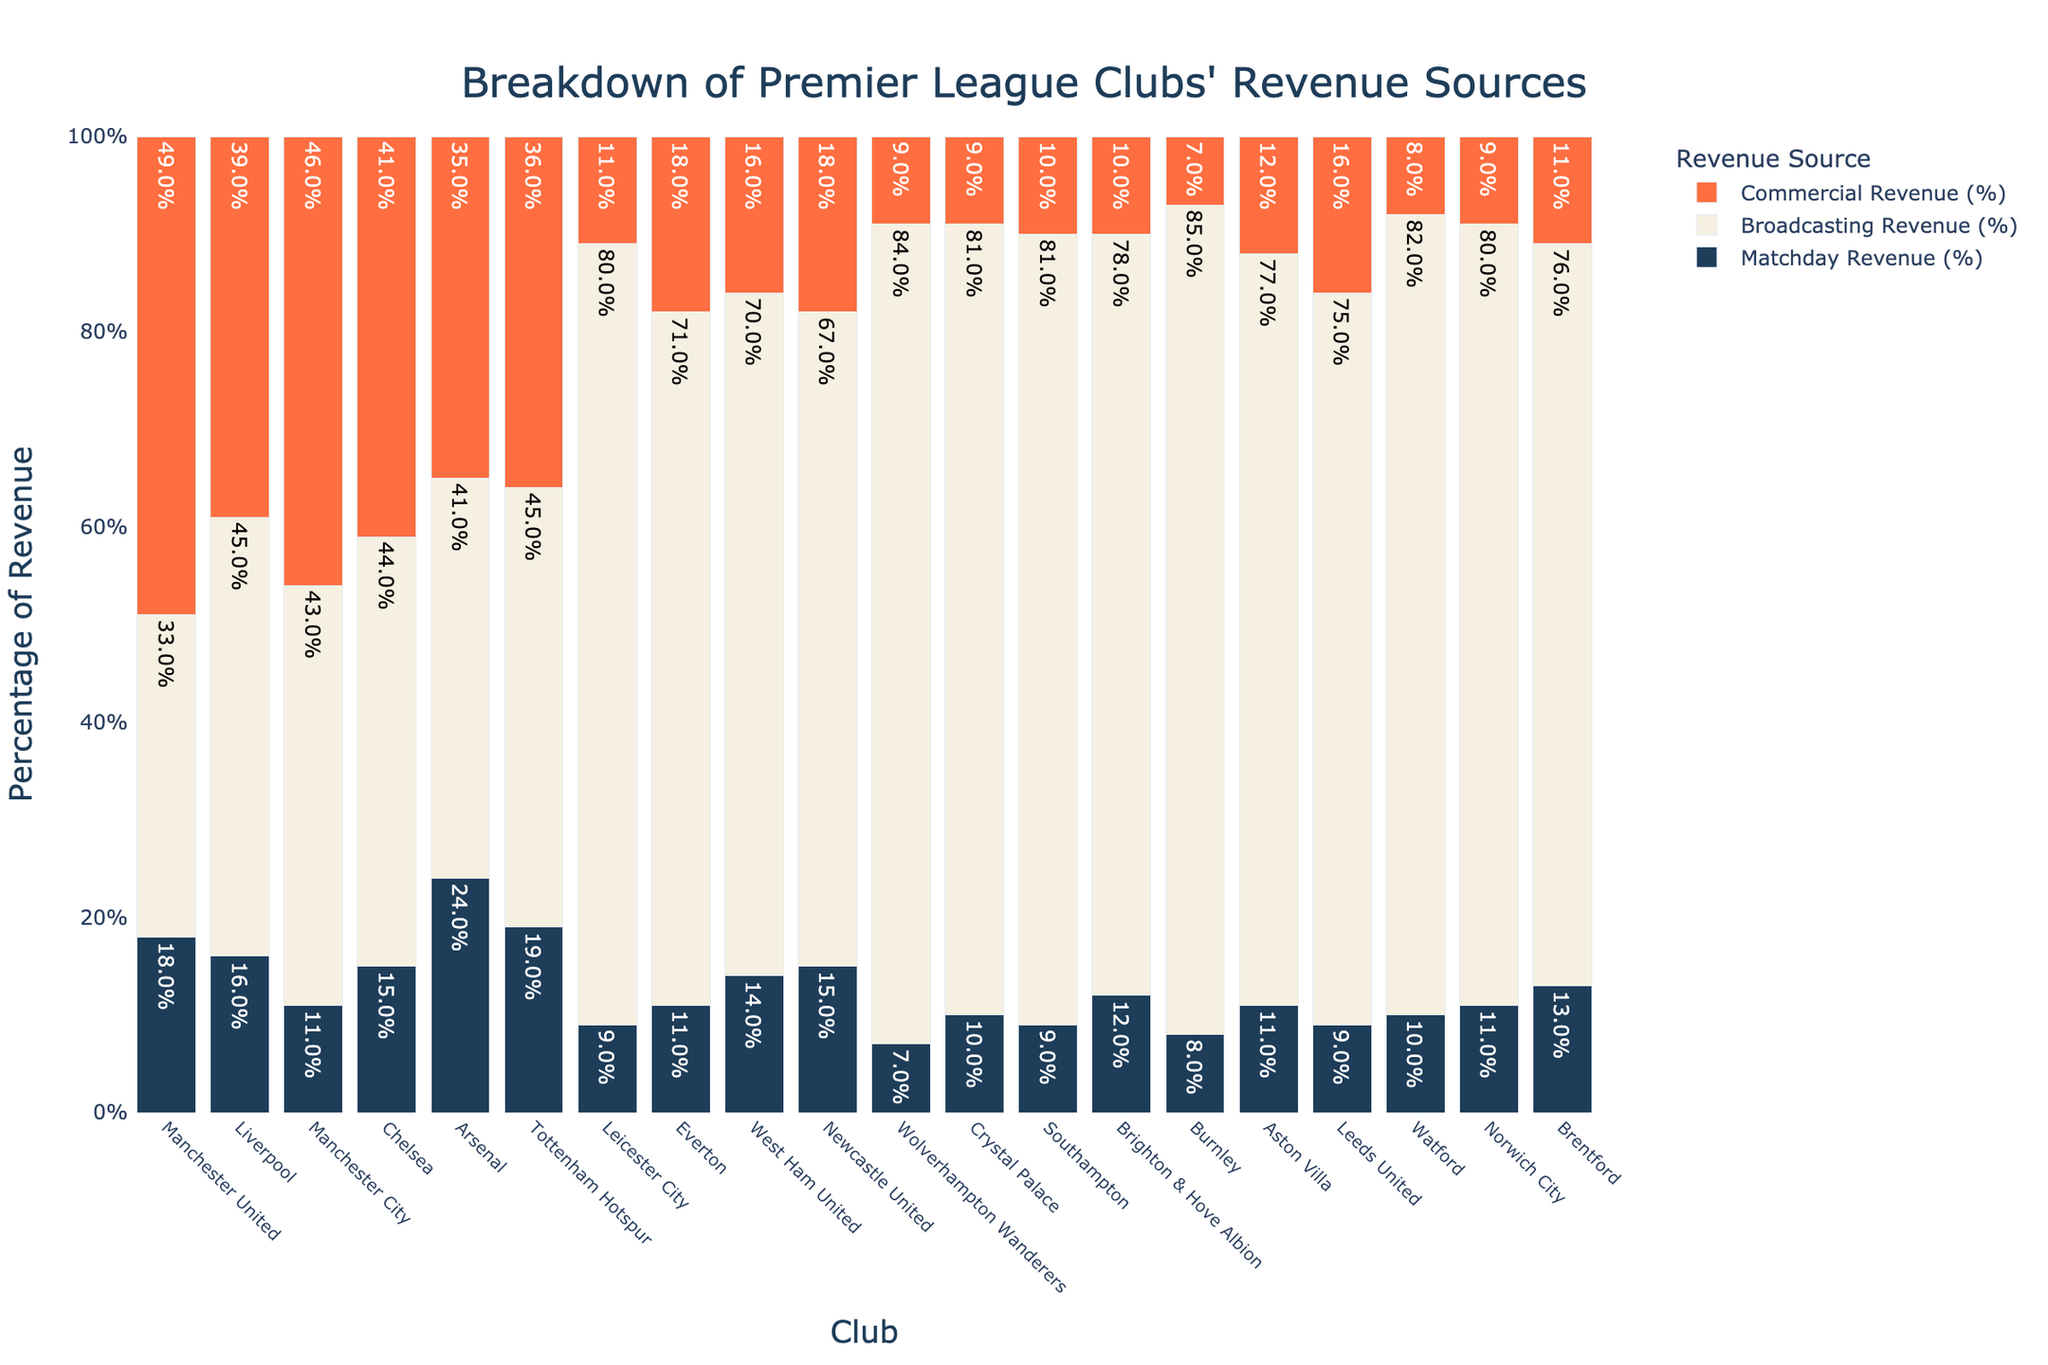Which club has the highest percentage of Revenue from Matchday? Arsenal has the highest percentage of Matchday Revenue at 24%. This can be seen by comparing the heights of the bars for Matchday Revenue for all clubs.
Answer: Arsenal Which club's revenue mainly comes from Broadcasting Revenue? Leicester City has the highest percentage of revenue from Broadcasting Revenue at 80%, indicating that the majority of their revenue comes from broadcasting.
Answer: Leicester City What is the sum of Commercial Revenue percentages for Manchester United and Manchester City? From the figure, Manchester United has 49% and Manchester City has 46% of Commercial Revenue. Adding these percentages: 49% + 46% = 95%.
Answer: 95% Which club has the smallest percentage of Commercial Revenue and what is it? Wolverhampton Wanderers and Crystal Palace both have the smallest percentage of Commercial Revenue at 9%. This can be observed by identifying the shortest bars for Commercial Revenue.
Answer: Wolverhampton Wanderers and Crystal Palace Compare the Matchday Revenue of Arsenal and Tottenham Hotspur. Which club has a higher percentage and by how much? Arsenal has 24% Matchday Revenue, while Tottenham Hotspur has 19%. The difference is 24% - 19% = 5%.
Answer: Arsenal by 5% How much higher is the Broadcasting Revenue percentage of Wolverhampton Wanderers compared to Newcastle United? Wolverhampton Wanderers have 84% Broadcasting Revenue, and Newcastle United have 67%. The difference is 84% - 67% = 17%.
Answer: 17% Does any club have a Matchday Revenue higher than 20% besides Arsenal? Arsenal has a Matchday Revenue of 24%, and no other club has a Matchday Revenue higher than 20%, as seen in the figure.
Answer: No What is the total percentage of all Revenue sources for Burnley? The percentages for Burnley's Revenue sources are Matchday (8%), Broadcasting (85%), and Commercial (7%). Adding these: 8% + 85% + 7% = 100%.
Answer: 100% Which club has the closest match in terms of their Commercial Revenue and Matchday Revenue percentages? Tottenham Hotspur has 19% Matchday Revenue and 36% Commercial Revenue, with a difference of 17 percentage points. However, Manchester United has 18% Matchday Revenue and 49% Commercial Revenue, with a difference of 31 percentage points. Therefore, Tottenham Hotspur has the closest match between these two revenue sources.
Answer: Tottenham Hotspur 